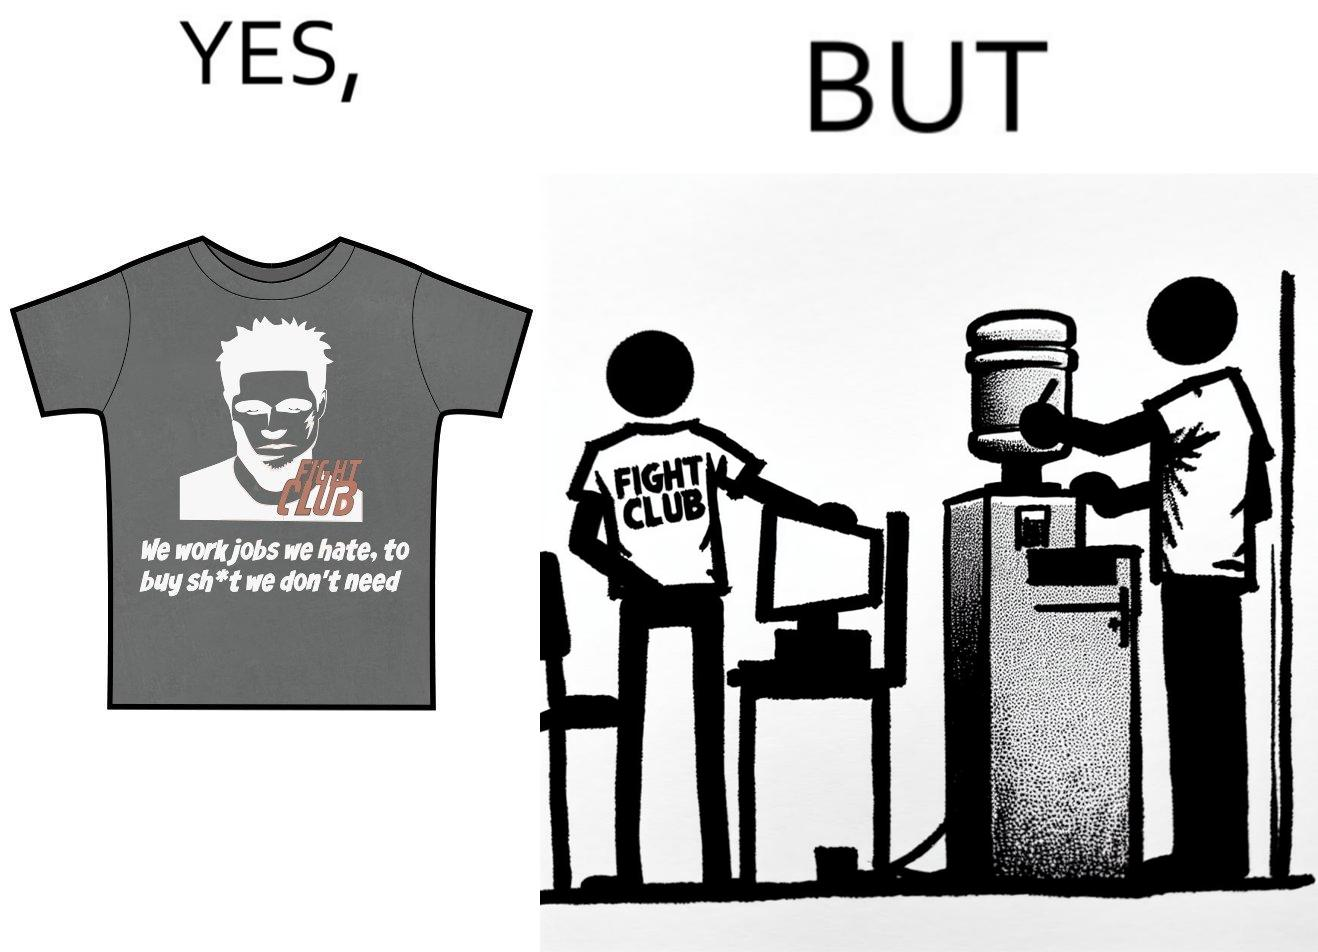Explain why this image is satirical. The image is ironical, as the t-shirt says "We work jobs we hate, to buy sh*t we don't need", which is a rebellious message against the construct of office jobs. However, the person wearing the t-shirt seems to be working in an office environment. Also, the t-shirt might have been bought using the money earned via the very same job. 